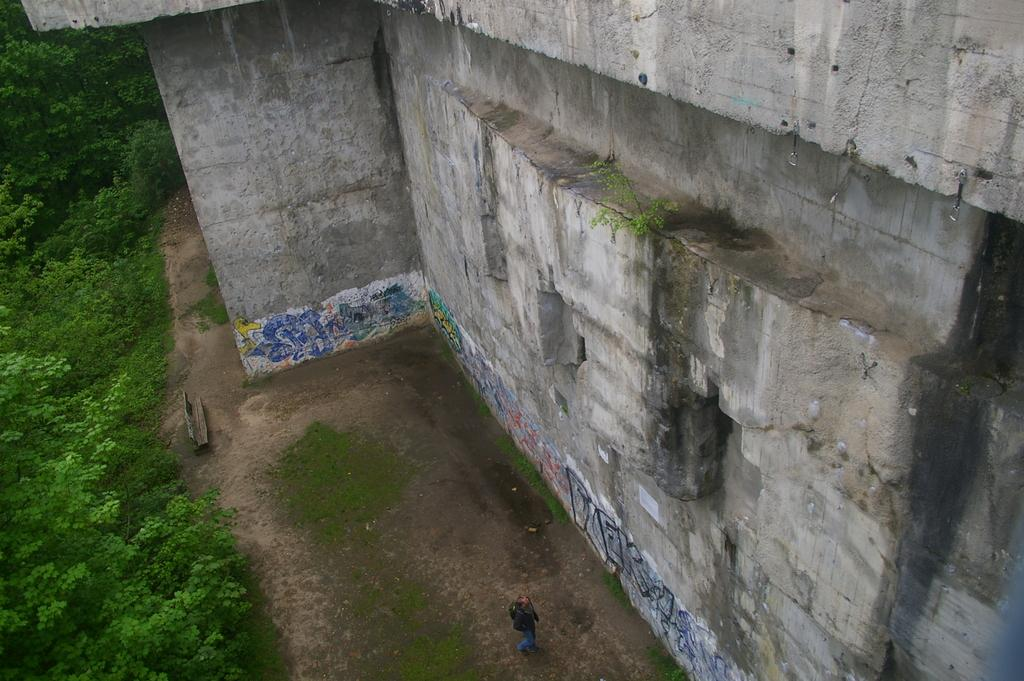What type of structure is present in the image? There is a wall in the image. Can you describe the person in the image? A person is standing at the bottom of the image. What type of seating is available in the image? There is a bench in the image. What type of vegetation can be seen in the image? Trees are visible in the image. What type of church can be seen in the image? There is no church present in the image; it only features a wall, a person, a bench, and trees. Can you tell me how many deer are visible in the image? There are no deer present in the image. 